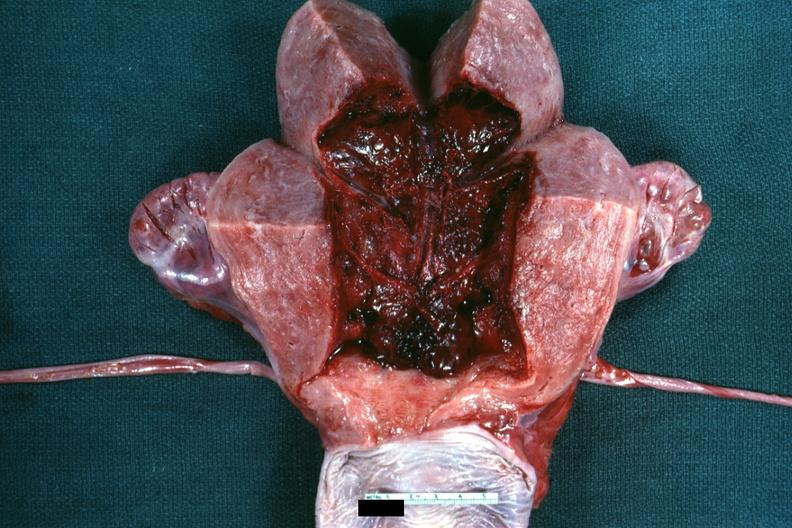s uterus present?
Answer the question using a single word or phrase. Yes 